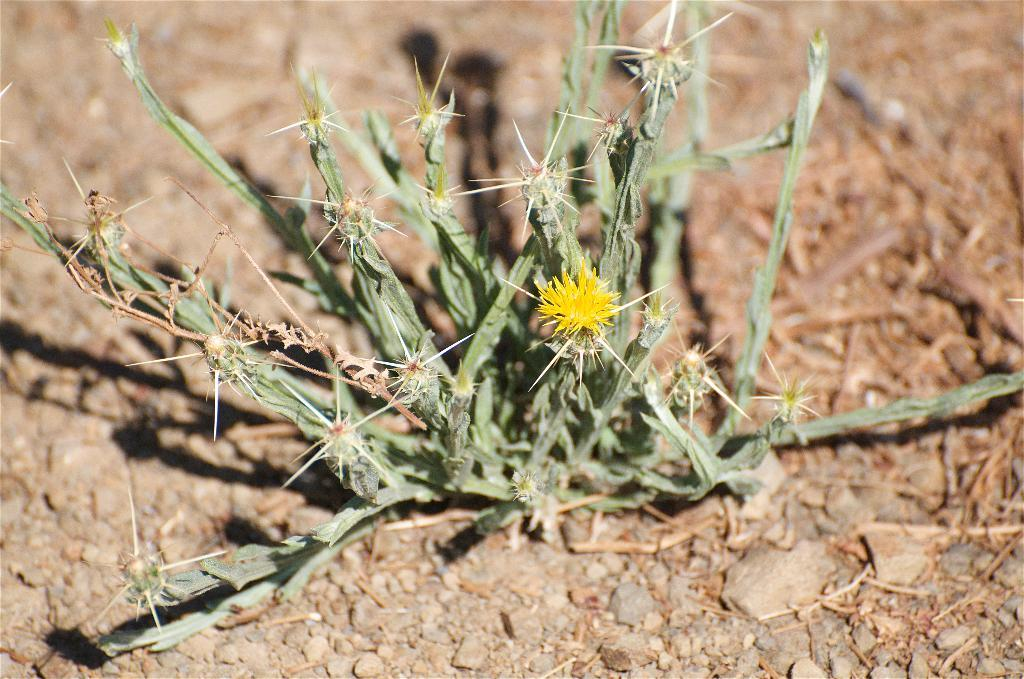What is the main subject in the center of the image? There is a plant in the center of the image. What other elements can be seen in the image? There are flowers, small stones at the bottom, and dry grass in the image. What type of question can be seen in the image? There is no question present in the image; it is a visual representation of a plant, flowers, small stones, and dry grass. 